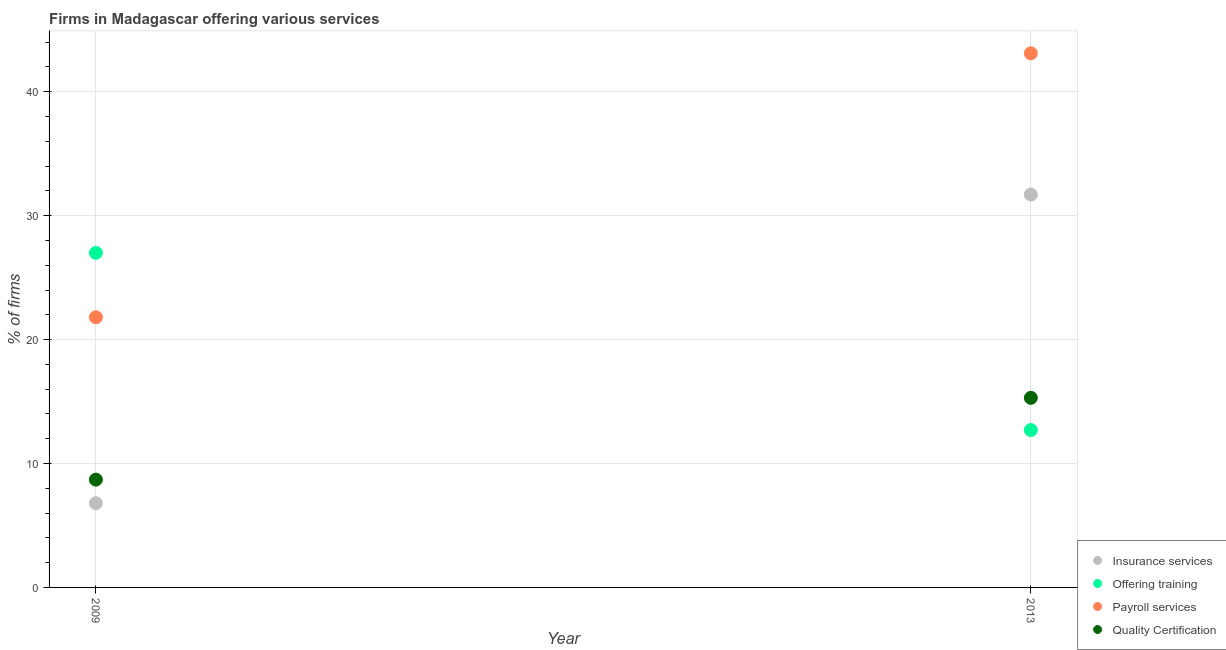How many different coloured dotlines are there?
Offer a terse response. 4. Is the number of dotlines equal to the number of legend labels?
Ensure brevity in your answer.  Yes. What is the percentage of firms offering quality certification in 2009?
Provide a succinct answer. 8.7. Across all years, what is the maximum percentage of firms offering training?
Give a very brief answer. 27. In which year was the percentage of firms offering insurance services maximum?
Offer a terse response. 2013. What is the total percentage of firms offering quality certification in the graph?
Your response must be concise. 24. What is the difference between the percentage of firms offering quality certification in 2009 and that in 2013?
Offer a terse response. -6.6. What is the average percentage of firms offering payroll services per year?
Give a very brief answer. 32.45. In how many years, is the percentage of firms offering quality certification greater than 16 %?
Provide a succinct answer. 0. What is the ratio of the percentage of firms offering payroll services in 2009 to that in 2013?
Offer a terse response. 0.51. Is it the case that in every year, the sum of the percentage of firms offering insurance services and percentage of firms offering training is greater than the percentage of firms offering payroll services?
Offer a terse response. Yes. Does the percentage of firms offering training monotonically increase over the years?
Offer a terse response. No. Is the percentage of firms offering payroll services strictly greater than the percentage of firms offering insurance services over the years?
Provide a short and direct response. Yes. How many years are there in the graph?
Your answer should be compact. 2. What is the difference between two consecutive major ticks on the Y-axis?
Your response must be concise. 10. Are the values on the major ticks of Y-axis written in scientific E-notation?
Offer a terse response. No. Does the graph contain grids?
Give a very brief answer. Yes. Where does the legend appear in the graph?
Keep it short and to the point. Bottom right. What is the title of the graph?
Offer a very short reply. Firms in Madagascar offering various services . What is the label or title of the Y-axis?
Offer a very short reply. % of firms. What is the % of firms of Insurance services in 2009?
Your answer should be compact. 6.8. What is the % of firms in Offering training in 2009?
Offer a terse response. 27. What is the % of firms of Payroll services in 2009?
Your answer should be compact. 21.8. What is the % of firms in Insurance services in 2013?
Offer a terse response. 31.7. What is the % of firms in Payroll services in 2013?
Provide a succinct answer. 43.1. Across all years, what is the maximum % of firms in Insurance services?
Make the answer very short. 31.7. Across all years, what is the maximum % of firms of Offering training?
Give a very brief answer. 27. Across all years, what is the maximum % of firms of Payroll services?
Provide a short and direct response. 43.1. Across all years, what is the minimum % of firms in Offering training?
Offer a terse response. 12.7. Across all years, what is the minimum % of firms of Payroll services?
Make the answer very short. 21.8. Across all years, what is the minimum % of firms in Quality Certification?
Your response must be concise. 8.7. What is the total % of firms in Insurance services in the graph?
Offer a very short reply. 38.5. What is the total % of firms in Offering training in the graph?
Provide a short and direct response. 39.7. What is the total % of firms of Payroll services in the graph?
Your response must be concise. 64.9. What is the difference between the % of firms of Insurance services in 2009 and that in 2013?
Your answer should be compact. -24.9. What is the difference between the % of firms of Offering training in 2009 and that in 2013?
Your response must be concise. 14.3. What is the difference between the % of firms of Payroll services in 2009 and that in 2013?
Your answer should be compact. -21.3. What is the difference between the % of firms in Quality Certification in 2009 and that in 2013?
Your answer should be compact. -6.6. What is the difference between the % of firms of Insurance services in 2009 and the % of firms of Offering training in 2013?
Your answer should be very brief. -5.9. What is the difference between the % of firms in Insurance services in 2009 and the % of firms in Payroll services in 2013?
Provide a succinct answer. -36.3. What is the difference between the % of firms of Insurance services in 2009 and the % of firms of Quality Certification in 2013?
Ensure brevity in your answer.  -8.5. What is the difference between the % of firms of Offering training in 2009 and the % of firms of Payroll services in 2013?
Offer a terse response. -16.1. What is the difference between the % of firms of Payroll services in 2009 and the % of firms of Quality Certification in 2013?
Provide a short and direct response. 6.5. What is the average % of firms of Insurance services per year?
Offer a very short reply. 19.25. What is the average % of firms in Offering training per year?
Make the answer very short. 19.85. What is the average % of firms of Payroll services per year?
Keep it short and to the point. 32.45. In the year 2009, what is the difference between the % of firms of Insurance services and % of firms of Offering training?
Offer a very short reply. -20.2. In the year 2009, what is the difference between the % of firms of Insurance services and % of firms of Quality Certification?
Offer a terse response. -1.9. In the year 2009, what is the difference between the % of firms of Payroll services and % of firms of Quality Certification?
Keep it short and to the point. 13.1. In the year 2013, what is the difference between the % of firms in Insurance services and % of firms in Offering training?
Your answer should be very brief. 19. In the year 2013, what is the difference between the % of firms of Insurance services and % of firms of Payroll services?
Offer a terse response. -11.4. In the year 2013, what is the difference between the % of firms of Offering training and % of firms of Payroll services?
Provide a succinct answer. -30.4. In the year 2013, what is the difference between the % of firms in Offering training and % of firms in Quality Certification?
Your answer should be very brief. -2.6. In the year 2013, what is the difference between the % of firms of Payroll services and % of firms of Quality Certification?
Ensure brevity in your answer.  27.8. What is the ratio of the % of firms of Insurance services in 2009 to that in 2013?
Provide a succinct answer. 0.21. What is the ratio of the % of firms in Offering training in 2009 to that in 2013?
Your answer should be very brief. 2.13. What is the ratio of the % of firms of Payroll services in 2009 to that in 2013?
Your answer should be compact. 0.51. What is the ratio of the % of firms in Quality Certification in 2009 to that in 2013?
Give a very brief answer. 0.57. What is the difference between the highest and the second highest % of firms of Insurance services?
Make the answer very short. 24.9. What is the difference between the highest and the second highest % of firms of Payroll services?
Offer a very short reply. 21.3. What is the difference between the highest and the lowest % of firms of Insurance services?
Give a very brief answer. 24.9. What is the difference between the highest and the lowest % of firms of Payroll services?
Ensure brevity in your answer.  21.3. 